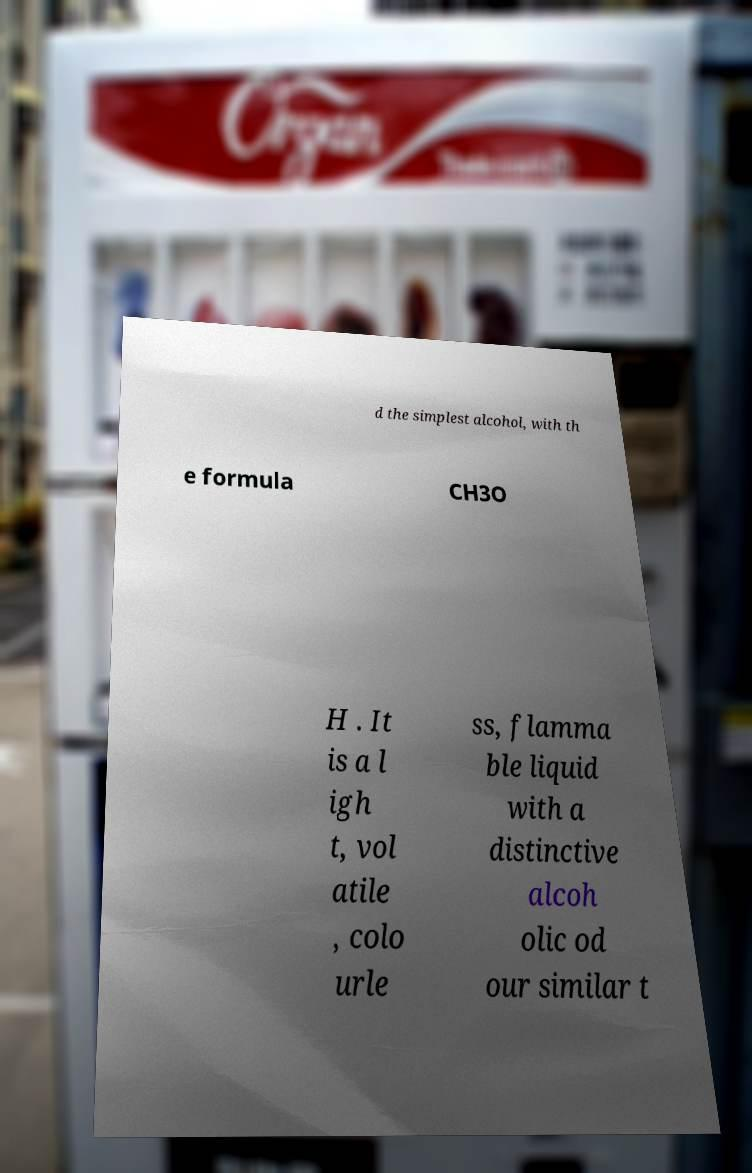Please identify and transcribe the text found in this image. d the simplest alcohol, with th e formula CH3O H . It is a l igh t, vol atile , colo urle ss, flamma ble liquid with a distinctive alcoh olic od our similar t 